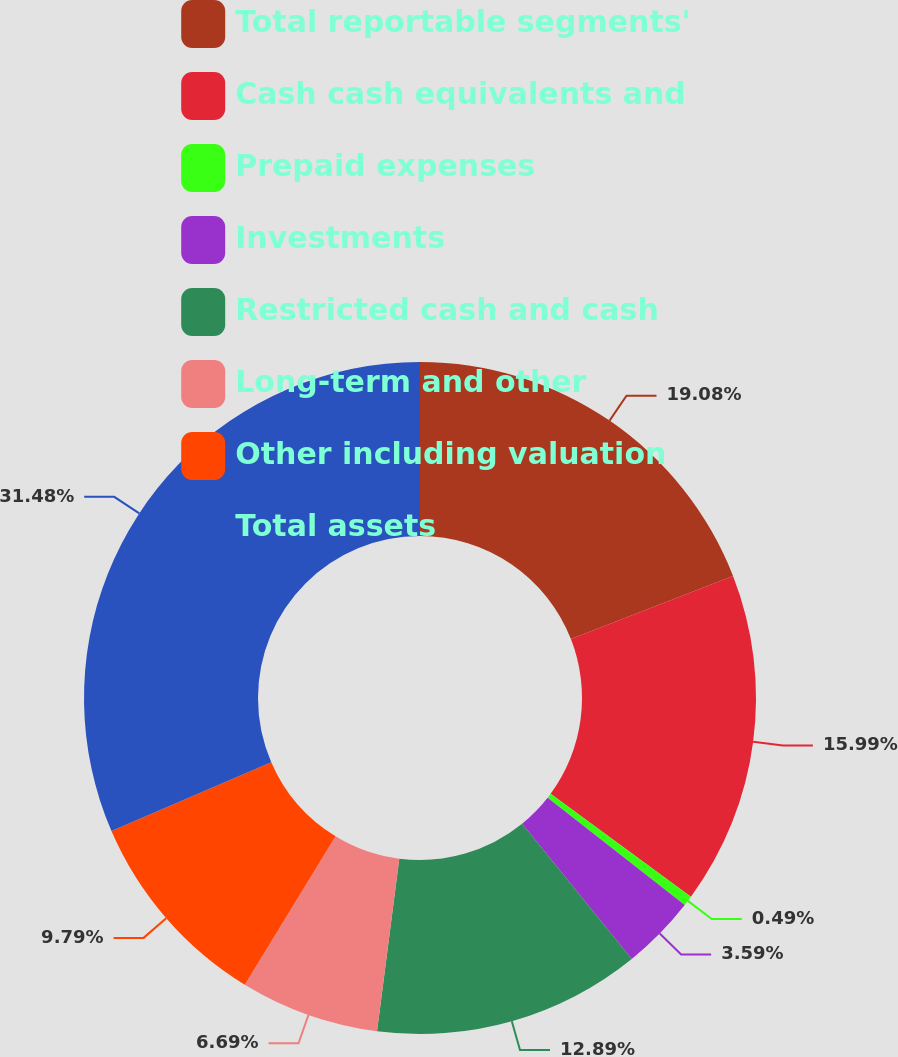Convert chart. <chart><loc_0><loc_0><loc_500><loc_500><pie_chart><fcel>Total reportable segments'<fcel>Cash cash equivalents and<fcel>Prepaid expenses<fcel>Investments<fcel>Restricted cash and cash<fcel>Long-term and other<fcel>Other including valuation<fcel>Total assets<nl><fcel>19.08%<fcel>15.99%<fcel>0.49%<fcel>3.59%<fcel>12.89%<fcel>6.69%<fcel>9.79%<fcel>31.48%<nl></chart> 